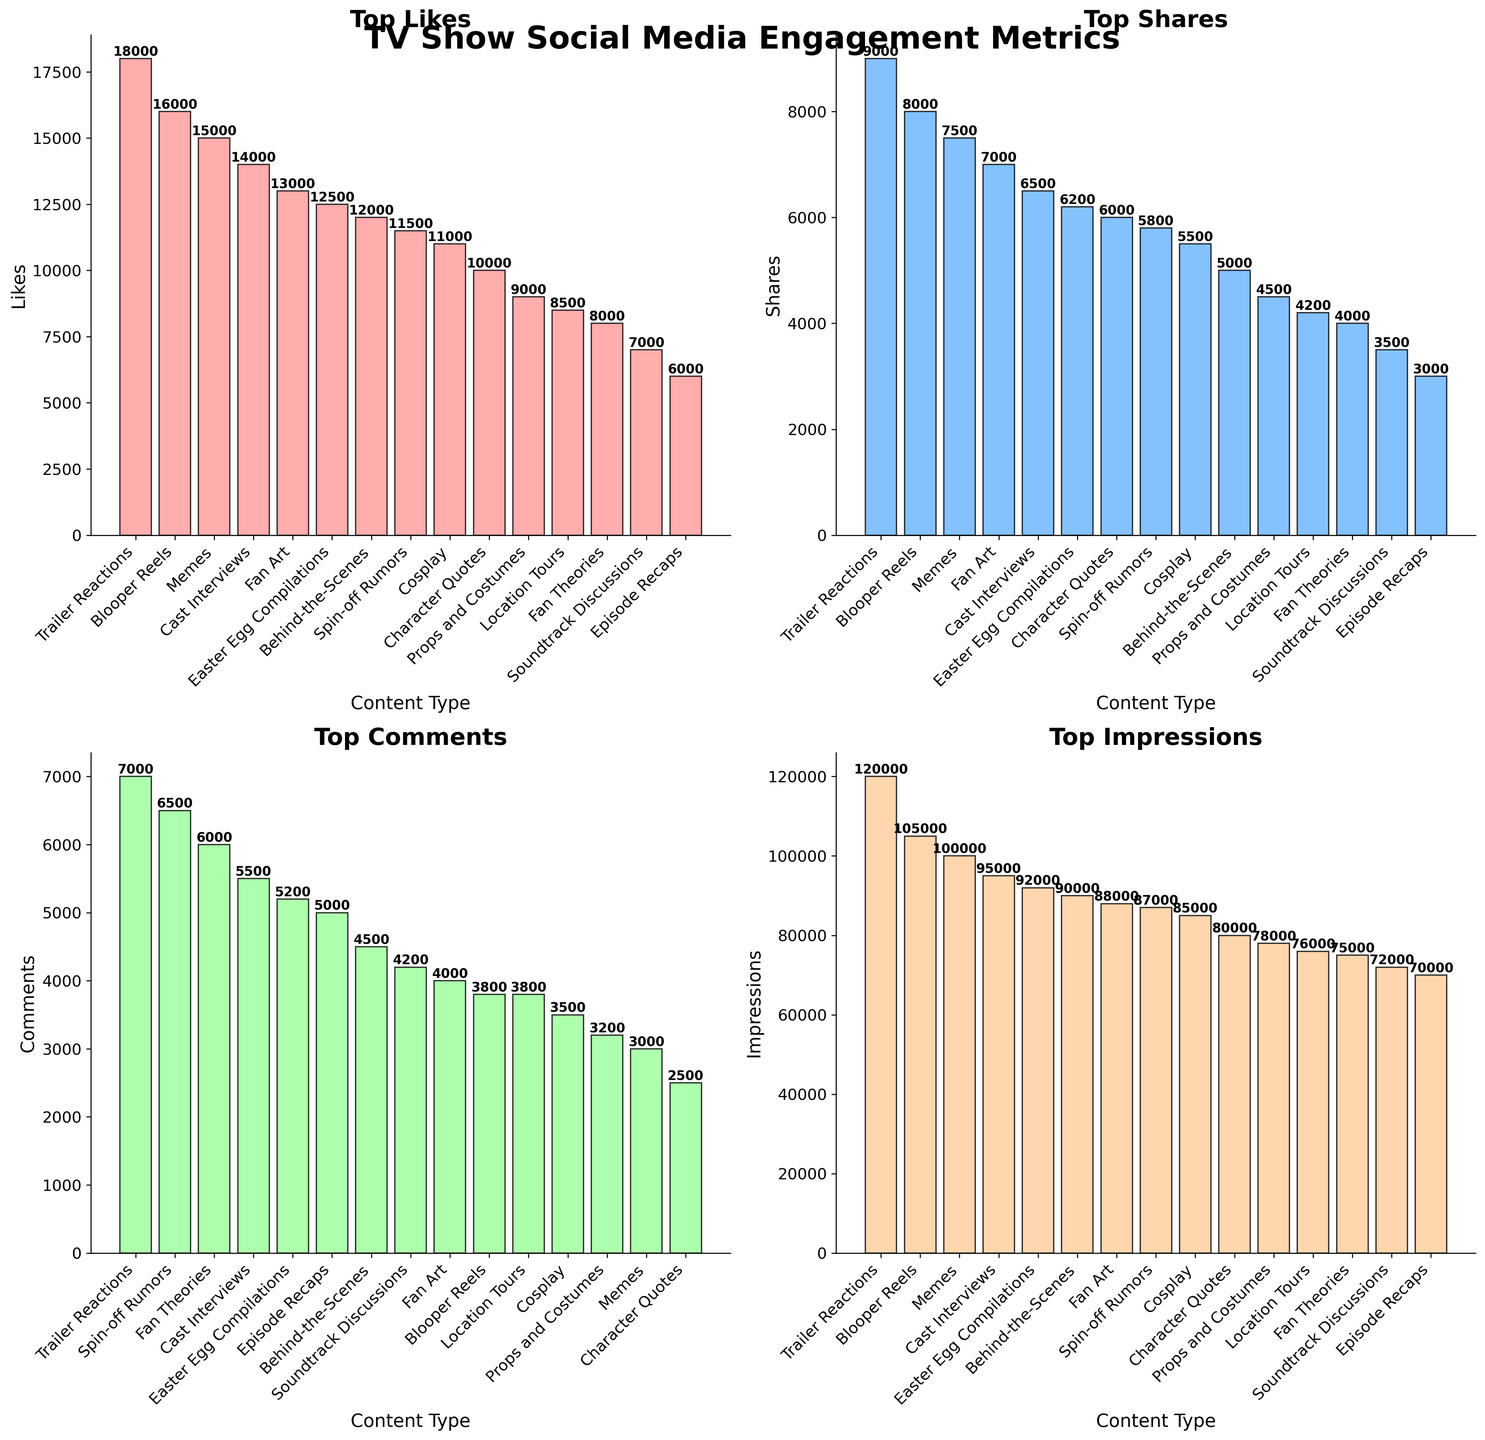Which content type has the highest number of likes? By looking at the "Top Likes" subplot, we see that the highest bar represents "Trailer Reactions". The height of this bar indicates the highest number of likes.
Answer: Trailer Reactions Which content type has the lowest number of shares? In the "Top Shares" subplot, the smallest bar corresponds to "Episode Recaps". This indicates that "Episode Recaps" has the lowest number of shares.
Answer: Episode Recaps What is the total number of comments for the top three content types with the highest comments? In the "Top Comments" subplot, the three tallest bars correspond to "Trailer Reactions", "Spin-off Rumors", and "Fan Theories". Their values are 7000, 6500, and 6000 respectively. Summing them gives 7000 + 6500 + 6000 = 19500.
Answer: 19500 Which content type has more likes, "Memes" or "Character Quotes"? By comparing the bars in the "Top Likes" subplot, we see the bar for "Memes" is taller than the bar for "Character Quotes". Therefore, "Memes" have more likes.
Answer: Memes What is the average number of impressions across all content types? In the "Top Impressions" subplot, sum up all the values of impressions and divide by the number of content types. The sum is 100000 + 75000 + 90000 + 80000 + 70000 + 120000 + 95000 + 85000 + 88000 + 105000 + 72000 + 78000 + 76000 + 92000 + 87000 = 1353000. There are 15 content types, so the average is 1353000 / 15 = 90200.
Answer: 90200 How many more shares does "Trailer Reactions" have compared to "Props and Costumes"? In the "Top Shares" subplot, the number of shares for "Trailer Reactions" is 9000 and for "Props and Costumes" is 4500. The difference is 9000 - 4500 = 4500.
Answer: 4500 